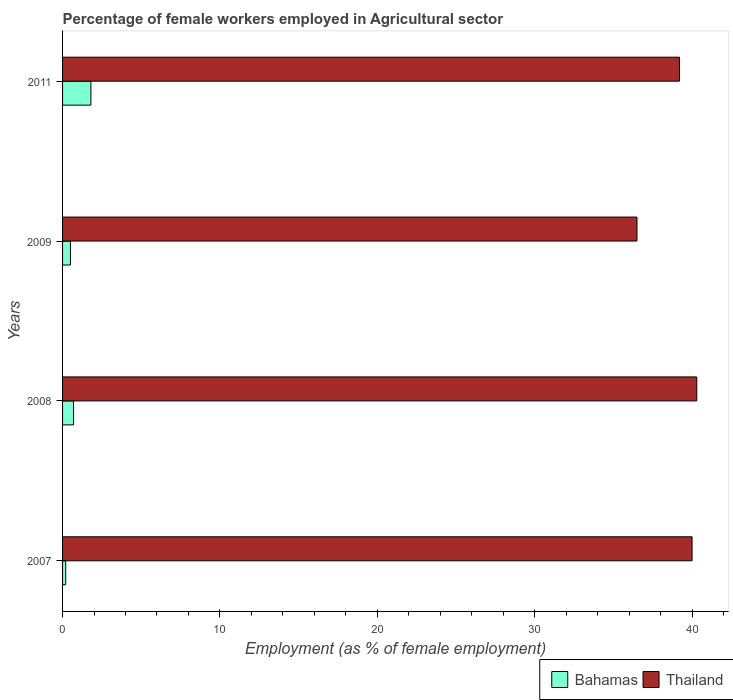How many groups of bars are there?
Offer a terse response. 4. Are the number of bars on each tick of the Y-axis equal?
Your answer should be very brief. Yes. How many bars are there on the 2nd tick from the top?
Provide a succinct answer. 2. How many bars are there on the 4th tick from the bottom?
Give a very brief answer. 2. What is the label of the 3rd group of bars from the top?
Your answer should be compact. 2008. Across all years, what is the maximum percentage of females employed in Agricultural sector in Bahamas?
Provide a short and direct response. 1.8. Across all years, what is the minimum percentage of females employed in Agricultural sector in Thailand?
Make the answer very short. 36.5. In which year was the percentage of females employed in Agricultural sector in Thailand maximum?
Give a very brief answer. 2008. In which year was the percentage of females employed in Agricultural sector in Thailand minimum?
Your answer should be compact. 2009. What is the total percentage of females employed in Agricultural sector in Thailand in the graph?
Your answer should be compact. 156. What is the difference between the percentage of females employed in Agricultural sector in Thailand in 2008 and that in 2011?
Your response must be concise. 1.1. What is the difference between the percentage of females employed in Agricultural sector in Bahamas in 2009 and the percentage of females employed in Agricultural sector in Thailand in 2007?
Make the answer very short. -39.5. In the year 2011, what is the difference between the percentage of females employed in Agricultural sector in Thailand and percentage of females employed in Agricultural sector in Bahamas?
Keep it short and to the point. 37.4. In how many years, is the percentage of females employed in Agricultural sector in Bahamas greater than 30 %?
Offer a very short reply. 0. What is the ratio of the percentage of females employed in Agricultural sector in Bahamas in 2008 to that in 2011?
Offer a very short reply. 0.39. What is the difference between the highest and the second highest percentage of females employed in Agricultural sector in Thailand?
Ensure brevity in your answer.  0.3. What is the difference between the highest and the lowest percentage of females employed in Agricultural sector in Thailand?
Offer a terse response. 3.8. In how many years, is the percentage of females employed in Agricultural sector in Bahamas greater than the average percentage of females employed in Agricultural sector in Bahamas taken over all years?
Ensure brevity in your answer.  1. Is the sum of the percentage of females employed in Agricultural sector in Bahamas in 2007 and 2008 greater than the maximum percentage of females employed in Agricultural sector in Thailand across all years?
Provide a short and direct response. No. What does the 2nd bar from the top in 2011 represents?
Your response must be concise. Bahamas. What does the 2nd bar from the bottom in 2009 represents?
Your response must be concise. Thailand. How many bars are there?
Provide a succinct answer. 8. Are all the bars in the graph horizontal?
Provide a short and direct response. Yes. How many years are there in the graph?
Provide a short and direct response. 4. Are the values on the major ticks of X-axis written in scientific E-notation?
Your answer should be compact. No. Does the graph contain any zero values?
Keep it short and to the point. No. How many legend labels are there?
Offer a very short reply. 2. How are the legend labels stacked?
Keep it short and to the point. Horizontal. What is the title of the graph?
Offer a terse response. Percentage of female workers employed in Agricultural sector. What is the label or title of the X-axis?
Your answer should be compact. Employment (as % of female employment). What is the label or title of the Y-axis?
Provide a succinct answer. Years. What is the Employment (as % of female employment) of Bahamas in 2007?
Keep it short and to the point. 0.2. What is the Employment (as % of female employment) in Thailand in 2007?
Give a very brief answer. 40. What is the Employment (as % of female employment) of Bahamas in 2008?
Your answer should be very brief. 0.7. What is the Employment (as % of female employment) in Thailand in 2008?
Keep it short and to the point. 40.3. What is the Employment (as % of female employment) in Thailand in 2009?
Ensure brevity in your answer.  36.5. What is the Employment (as % of female employment) in Bahamas in 2011?
Keep it short and to the point. 1.8. What is the Employment (as % of female employment) in Thailand in 2011?
Offer a terse response. 39.2. Across all years, what is the maximum Employment (as % of female employment) of Bahamas?
Provide a short and direct response. 1.8. Across all years, what is the maximum Employment (as % of female employment) of Thailand?
Your response must be concise. 40.3. Across all years, what is the minimum Employment (as % of female employment) of Bahamas?
Ensure brevity in your answer.  0.2. Across all years, what is the minimum Employment (as % of female employment) in Thailand?
Provide a succinct answer. 36.5. What is the total Employment (as % of female employment) of Bahamas in the graph?
Offer a terse response. 3.2. What is the total Employment (as % of female employment) of Thailand in the graph?
Offer a very short reply. 156. What is the difference between the Employment (as % of female employment) in Bahamas in 2007 and that in 2008?
Your answer should be very brief. -0.5. What is the difference between the Employment (as % of female employment) in Thailand in 2007 and that in 2008?
Ensure brevity in your answer.  -0.3. What is the difference between the Employment (as % of female employment) of Thailand in 2007 and that in 2009?
Keep it short and to the point. 3.5. What is the difference between the Employment (as % of female employment) in Bahamas in 2008 and that in 2009?
Ensure brevity in your answer.  0.2. What is the difference between the Employment (as % of female employment) of Bahamas in 2008 and that in 2011?
Your answer should be very brief. -1.1. What is the difference between the Employment (as % of female employment) of Bahamas in 2007 and the Employment (as % of female employment) of Thailand in 2008?
Provide a succinct answer. -40.1. What is the difference between the Employment (as % of female employment) of Bahamas in 2007 and the Employment (as % of female employment) of Thailand in 2009?
Provide a succinct answer. -36.3. What is the difference between the Employment (as % of female employment) in Bahamas in 2007 and the Employment (as % of female employment) in Thailand in 2011?
Offer a terse response. -39. What is the difference between the Employment (as % of female employment) of Bahamas in 2008 and the Employment (as % of female employment) of Thailand in 2009?
Give a very brief answer. -35.8. What is the difference between the Employment (as % of female employment) in Bahamas in 2008 and the Employment (as % of female employment) in Thailand in 2011?
Ensure brevity in your answer.  -38.5. What is the difference between the Employment (as % of female employment) in Bahamas in 2009 and the Employment (as % of female employment) in Thailand in 2011?
Your response must be concise. -38.7. What is the average Employment (as % of female employment) in Bahamas per year?
Offer a very short reply. 0.8. What is the average Employment (as % of female employment) of Thailand per year?
Your answer should be compact. 39. In the year 2007, what is the difference between the Employment (as % of female employment) in Bahamas and Employment (as % of female employment) in Thailand?
Offer a very short reply. -39.8. In the year 2008, what is the difference between the Employment (as % of female employment) in Bahamas and Employment (as % of female employment) in Thailand?
Keep it short and to the point. -39.6. In the year 2009, what is the difference between the Employment (as % of female employment) in Bahamas and Employment (as % of female employment) in Thailand?
Offer a terse response. -36. In the year 2011, what is the difference between the Employment (as % of female employment) in Bahamas and Employment (as % of female employment) in Thailand?
Ensure brevity in your answer.  -37.4. What is the ratio of the Employment (as % of female employment) in Bahamas in 2007 to that in 2008?
Provide a succinct answer. 0.29. What is the ratio of the Employment (as % of female employment) in Thailand in 2007 to that in 2009?
Make the answer very short. 1.1. What is the ratio of the Employment (as % of female employment) of Thailand in 2007 to that in 2011?
Keep it short and to the point. 1.02. What is the ratio of the Employment (as % of female employment) of Bahamas in 2008 to that in 2009?
Your response must be concise. 1.4. What is the ratio of the Employment (as % of female employment) of Thailand in 2008 to that in 2009?
Your answer should be very brief. 1.1. What is the ratio of the Employment (as % of female employment) of Bahamas in 2008 to that in 2011?
Give a very brief answer. 0.39. What is the ratio of the Employment (as % of female employment) of Thailand in 2008 to that in 2011?
Your response must be concise. 1.03. What is the ratio of the Employment (as % of female employment) of Bahamas in 2009 to that in 2011?
Give a very brief answer. 0.28. What is the ratio of the Employment (as % of female employment) in Thailand in 2009 to that in 2011?
Offer a terse response. 0.93. What is the difference between the highest and the second highest Employment (as % of female employment) of Bahamas?
Offer a very short reply. 1.1. What is the difference between the highest and the lowest Employment (as % of female employment) in Bahamas?
Ensure brevity in your answer.  1.6. What is the difference between the highest and the lowest Employment (as % of female employment) of Thailand?
Offer a very short reply. 3.8. 